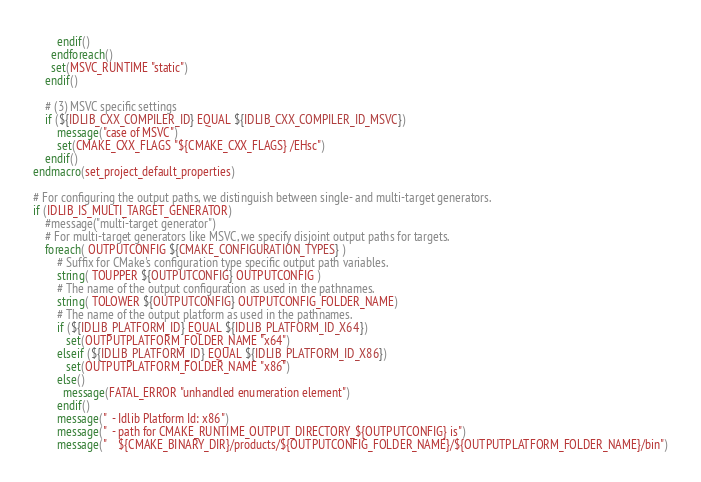Convert code to text. <code><loc_0><loc_0><loc_500><loc_500><_CMake_>		endif()
	  endforeach()
	  set(MSVC_RUNTIME "static")
	endif()

	# (3) MSVC specific settings
	if (${IDLIB_CXX_COMPILER_ID} EQUAL ${IDLIB_CXX_COMPILER_ID_MSVC})
	    message("case of MSVC")
		set(CMAKE_CXX_FLAGS "${CMAKE_CXX_FLAGS} /EHsc")
	endif()
endmacro(set_project_default_properties)

# For configuring the output paths, we distinguish between single- and multi-target generators.
if (IDLIB_IS_MULTI_TARGET_GENERATOR)
    #message("multi-target generator")
	# For multi-target generators like MSVC, we specify disjoint output paths for targets.
	foreach( OUTPUTCONFIG ${CMAKE_CONFIGURATION_TYPES} )
		# Suffix for CMake's configuration type specific output path variables.
		string( TOUPPER ${OUTPUTCONFIG} OUTPUTCONFIG )
		# The name of the output configuration as used in the pathnames.
		string( TOLOWER ${OUTPUTCONFIG} OUTPUTCONFIG_FOLDER_NAME)
		# The name of the output platform as used in the pathnames.
	    if (${IDLIB_PLATFORM_ID} EQUAL ${IDLIB_PLATFORM_ID_X64})
	       set(OUTPUTPLATFORM_FOLDER_NAME "x64")
		elseif (${IDLIB_PLATFORM_ID} EQUAL ${IDLIB_PLATFORM_ID_X86})
		   set(OUTPUTPLATFORM_FOLDER_NAME "x86")
		else()
	      message(FATAL_ERROR "unhandled enumeration element")		
		endif()
	    message("  - Idlib Platform Id: x86")
		message("  - path for CMAKE_RUNTIME_OUTPUT_DIRECTORY_${OUTPUTCONFIG} is")
		message("    ${CMAKE_BINARY_DIR}/products/${OUTPUTCONFIG_FOLDER_NAME}/${OUTPUTPLATFORM_FOLDER_NAME}/bin")</code> 